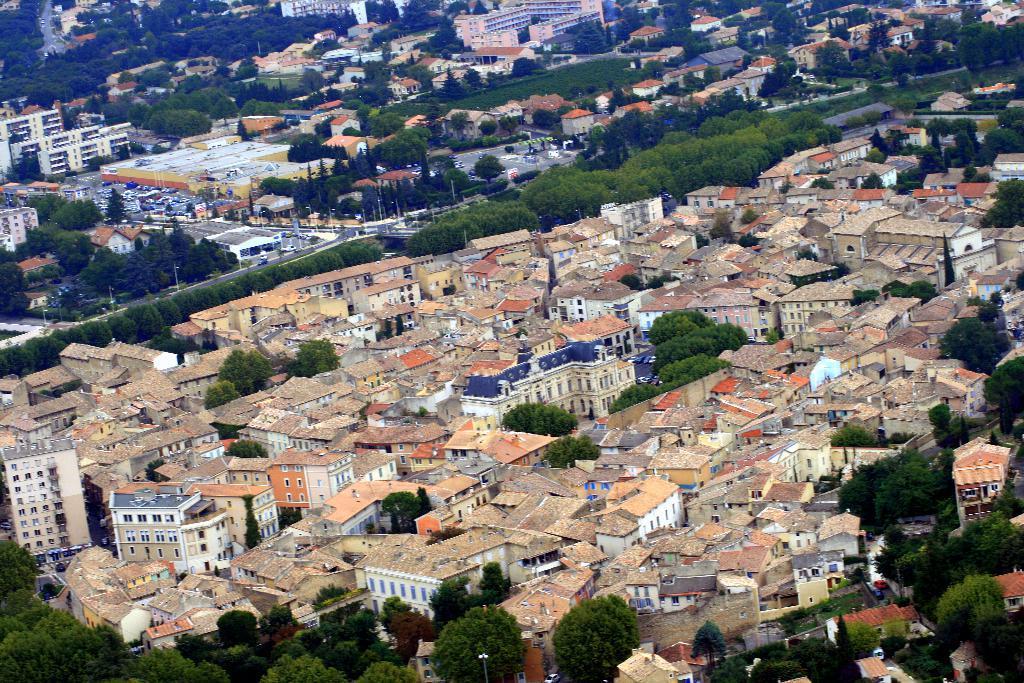Can you describe this image briefly? In this image there are some houses, buildings, trees and some poles. 